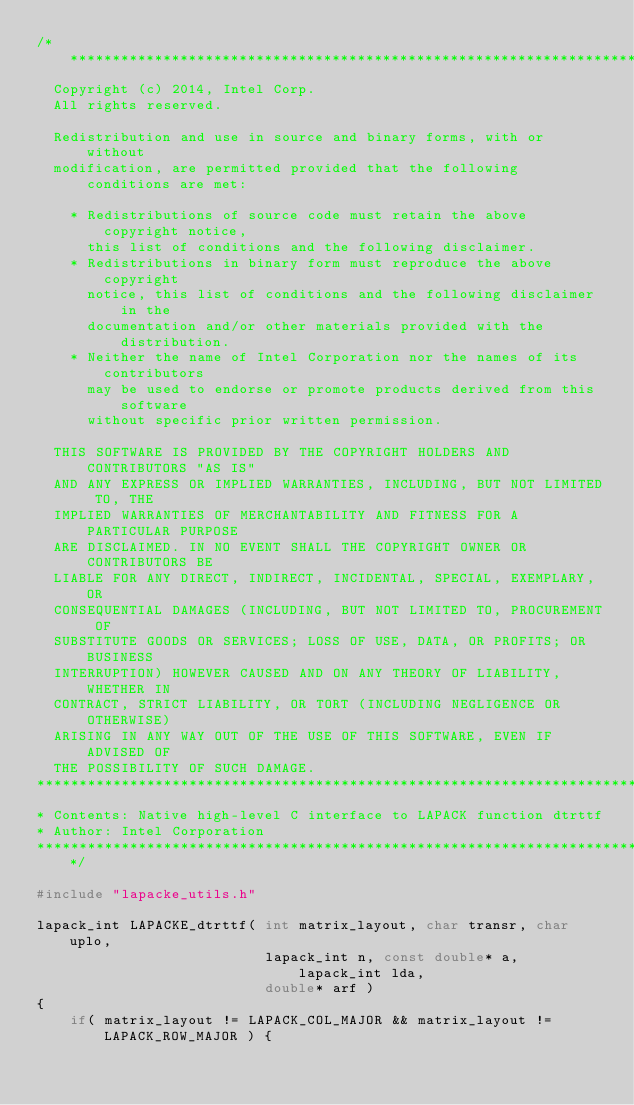<code> <loc_0><loc_0><loc_500><loc_500><_C_>/*****************************************************************************
  Copyright (c) 2014, Intel Corp.
  All rights reserved.

  Redistribution and use in source and binary forms, with or without
  modification, are permitted provided that the following conditions are met:

    * Redistributions of source code must retain the above copyright notice,
      this list of conditions and the following disclaimer.
    * Redistributions in binary form must reproduce the above copyright
      notice, this list of conditions and the following disclaimer in the
      documentation and/or other materials provided with the distribution.
    * Neither the name of Intel Corporation nor the names of its contributors
      may be used to endorse or promote products derived from this software
      without specific prior written permission.

  THIS SOFTWARE IS PROVIDED BY THE COPYRIGHT HOLDERS AND CONTRIBUTORS "AS IS"
  AND ANY EXPRESS OR IMPLIED WARRANTIES, INCLUDING, BUT NOT LIMITED TO, THE
  IMPLIED WARRANTIES OF MERCHANTABILITY AND FITNESS FOR A PARTICULAR PURPOSE
  ARE DISCLAIMED. IN NO EVENT SHALL THE COPYRIGHT OWNER OR CONTRIBUTORS BE
  LIABLE FOR ANY DIRECT, INDIRECT, INCIDENTAL, SPECIAL, EXEMPLARY, OR
  CONSEQUENTIAL DAMAGES (INCLUDING, BUT NOT LIMITED TO, PROCUREMENT OF
  SUBSTITUTE GOODS OR SERVICES; LOSS OF USE, DATA, OR PROFITS; OR BUSINESS
  INTERRUPTION) HOWEVER CAUSED AND ON ANY THEORY OF LIABILITY, WHETHER IN
  CONTRACT, STRICT LIABILITY, OR TORT (INCLUDING NEGLIGENCE OR OTHERWISE)
  ARISING IN ANY WAY OUT OF THE USE OF THIS SOFTWARE, EVEN IF ADVISED OF
  THE POSSIBILITY OF SUCH DAMAGE.
*****************************************************************************
* Contents: Native high-level C interface to LAPACK function dtrttf
* Author: Intel Corporation
*****************************************************************************/

#include "lapacke_utils.h"

lapack_int LAPACKE_dtrttf( int matrix_layout, char transr, char uplo,
                           lapack_int n, const double* a, lapack_int lda,
                           double* arf )
{
    if( matrix_layout != LAPACK_COL_MAJOR && matrix_layout != LAPACK_ROW_MAJOR ) {</code> 